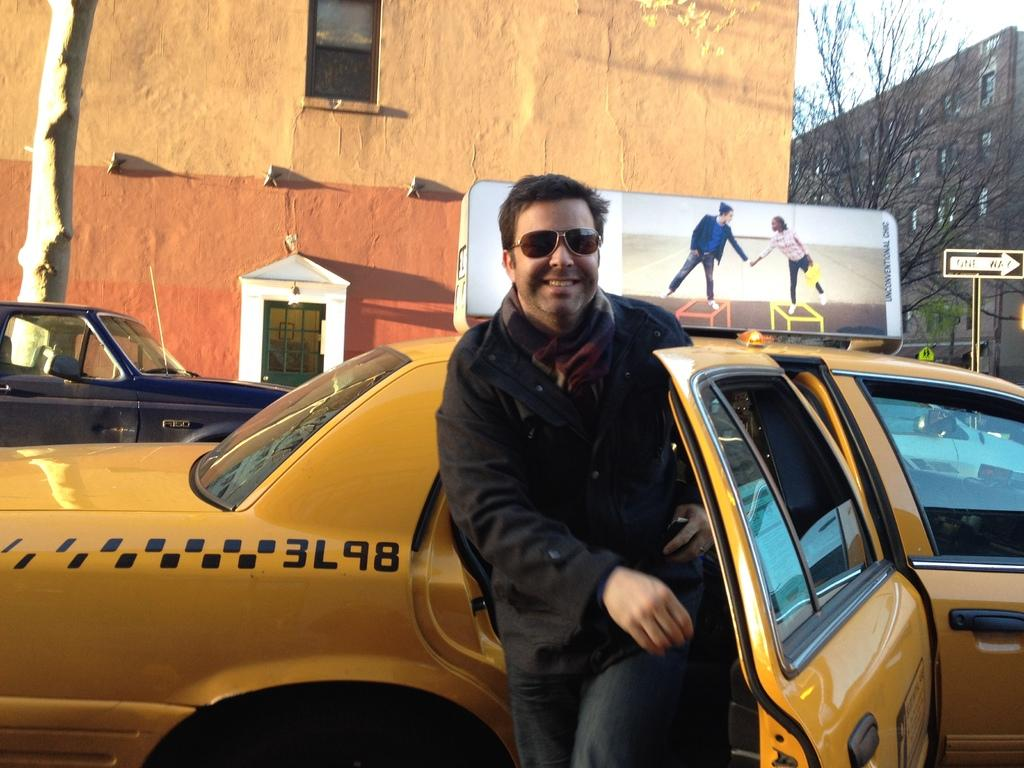What can be seen in the center of the image? There are two cars in the center of the image. What is the person in the image wearing? The person is wearing goggles. What can be seen in the background of the image? There are boards, buildings, a pole, trees, and some unspecified objects in the background of the image. What type of coast can be seen in the image? There is no coast visible in the image. What kind of laborer is working on the pole in the background? There is no laborer or pole visible in the image. 